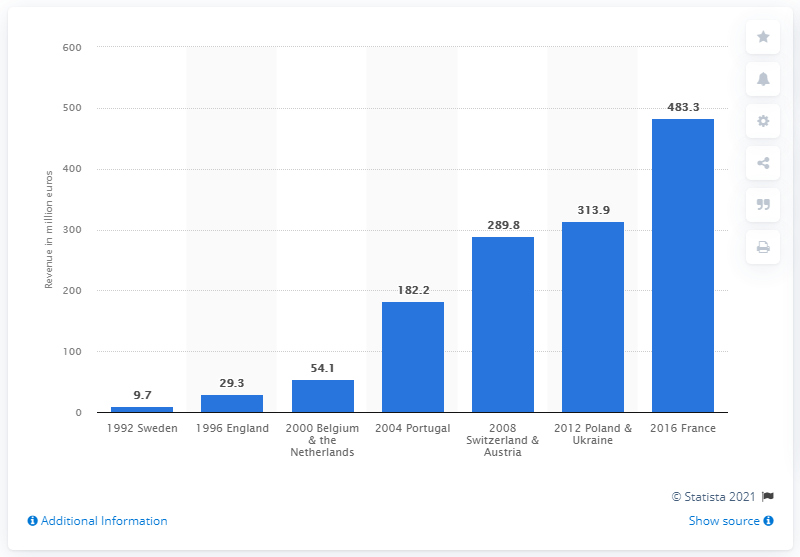Give some essential details in this illustration. The revenue generated from sponsorship, licensing, and merchandising at the 2008 EURO in Switzerland and Austria was 289.8 million. 